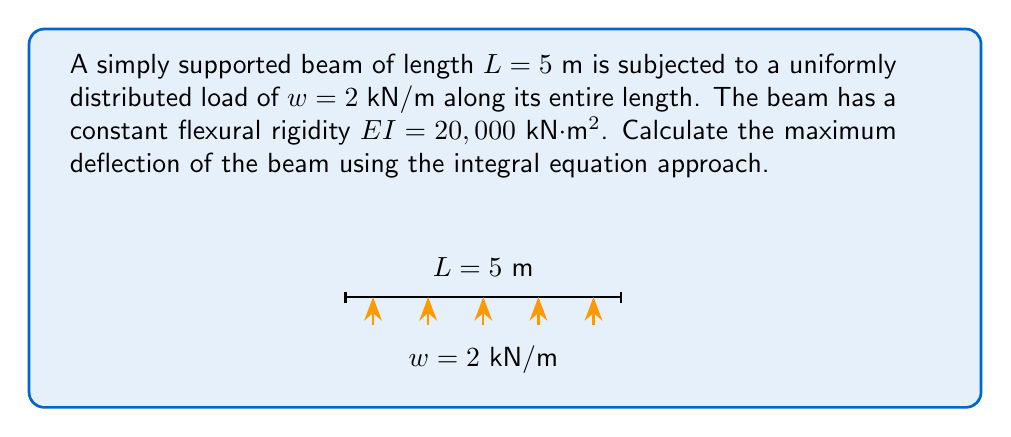Provide a solution to this math problem. Let's solve this step-by-step using the integral equation approach:

1) The general equation for beam deflection is:

   $$EI \frac{d^2y}{dx^2} = M(x)$$

   where $M(x)$ is the bending moment at any point $x$.

2) For a simply supported beam with uniformly distributed load, the bending moment is:

   $$M(x) = \frac{wx}{2}(L-x)$$

3) Substituting this into the deflection equation:

   $$EI \frac{d^2y}{dx^2} = \frac{wx}{2}(L-x)$$

4) Integrate twice to get the deflection equation:

   $$EI \frac{dy}{dx} = \frac{w}{2}(\frac{x^2L}{2} - \frac{x^3}{3}) + C_1$$

   $$EIy = \frac{w}{2}(\frac{x^3L}{6} - \frac{x^4}{12}) + C_1x + C_2$$

5) Apply boundary conditions:
   At $x = 0$ and $x = L$, $y = 0$

   At $x = 0$: $0 = C_2$
   At $x = L$: $0 = \frac{wL^4}{24} + C_1L$

   Solving for $C_1$: $C_1 = -\frac{wL^3}{24}$

6) The deflection equation becomes:

   $$y = \frac{w}{24EI}(x^3L - 2Lx^3 + x^4)$$

7) The maximum deflection occurs at the midspan $(x = L/2)$. Substituting:

   $$y_{max} = \frac{w}{24EI}(\frac{L^4}{16} - \frac{L^4}{4} + \frac{L^4}{16}) = -\frac{5wL^4}{384EI}$$

8) Plug in the given values:
   $w = 2$ kN/m, $L = 5$ m, $EI = 20,000$ kN·m²

   $$y_{max} = -\frac{5 \cdot 2 \cdot 5^4}{384 \cdot 20,000} = -0.00407$$

Therefore, the maximum deflection is 0.00407 m or 4.07 mm downward.
Answer: $4.07$ mm downward 